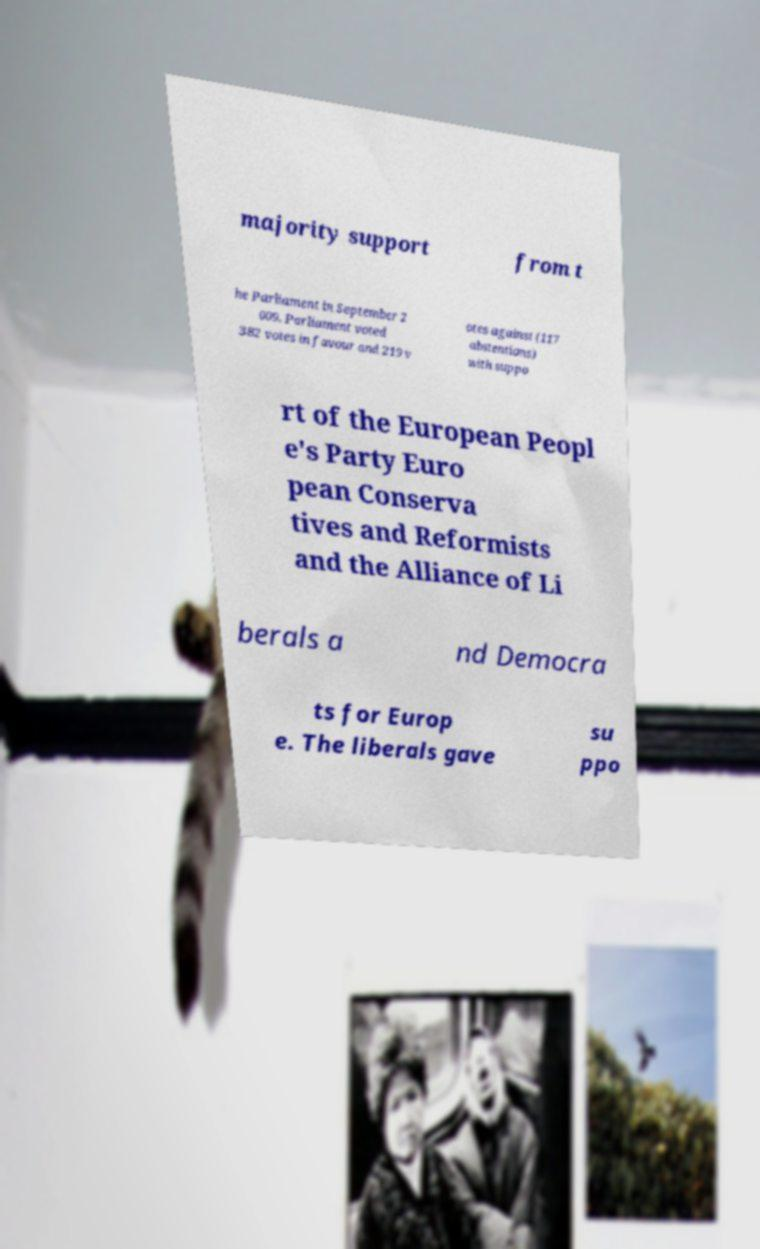What messages or text are displayed in this image? I need them in a readable, typed format. majority support from t he Parliament in September 2 009. Parliament voted 382 votes in favour and 219 v otes against (117 abstentions) with suppo rt of the European Peopl e's Party Euro pean Conserva tives and Reformists and the Alliance of Li berals a nd Democra ts for Europ e. The liberals gave su ppo 